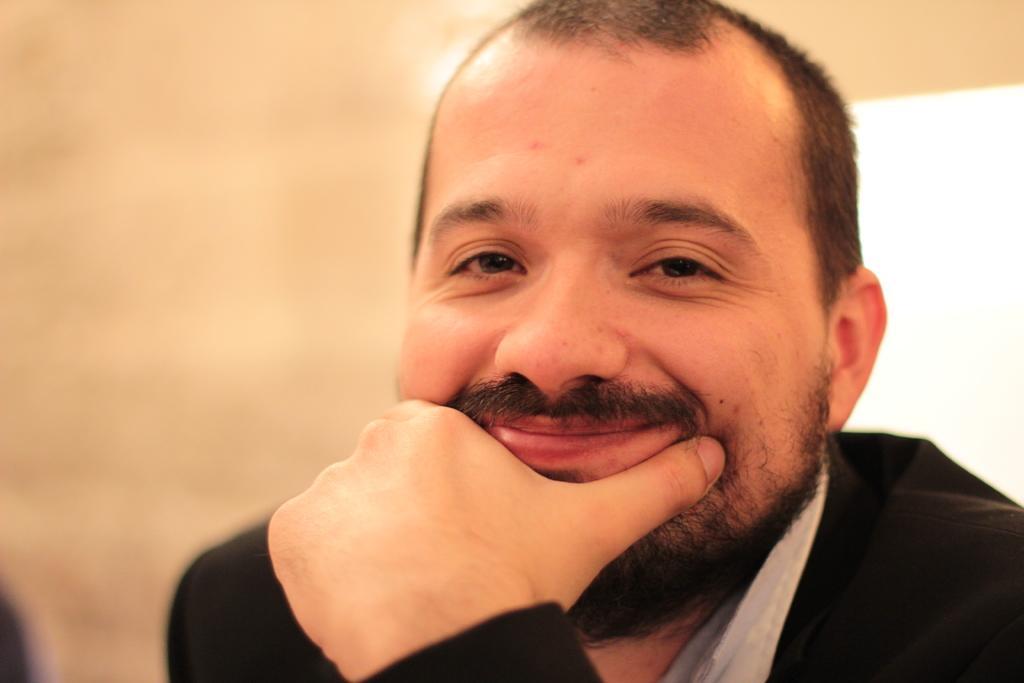How would you summarize this image in a sentence or two? In this image, I can see a man smiling. There is a blurred background. 